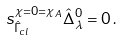<formula> <loc_0><loc_0><loc_500><loc_500>s _ { \hat { \Gamma } _ { c l } } ^ { \chi = 0 = \chi _ { A } } \hat { \Delta } _ { \lambda } ^ { 0 } = 0 \, .</formula> 